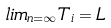<formula> <loc_0><loc_0><loc_500><loc_500>l i m _ { n = \infty } T _ { i } = L</formula> 